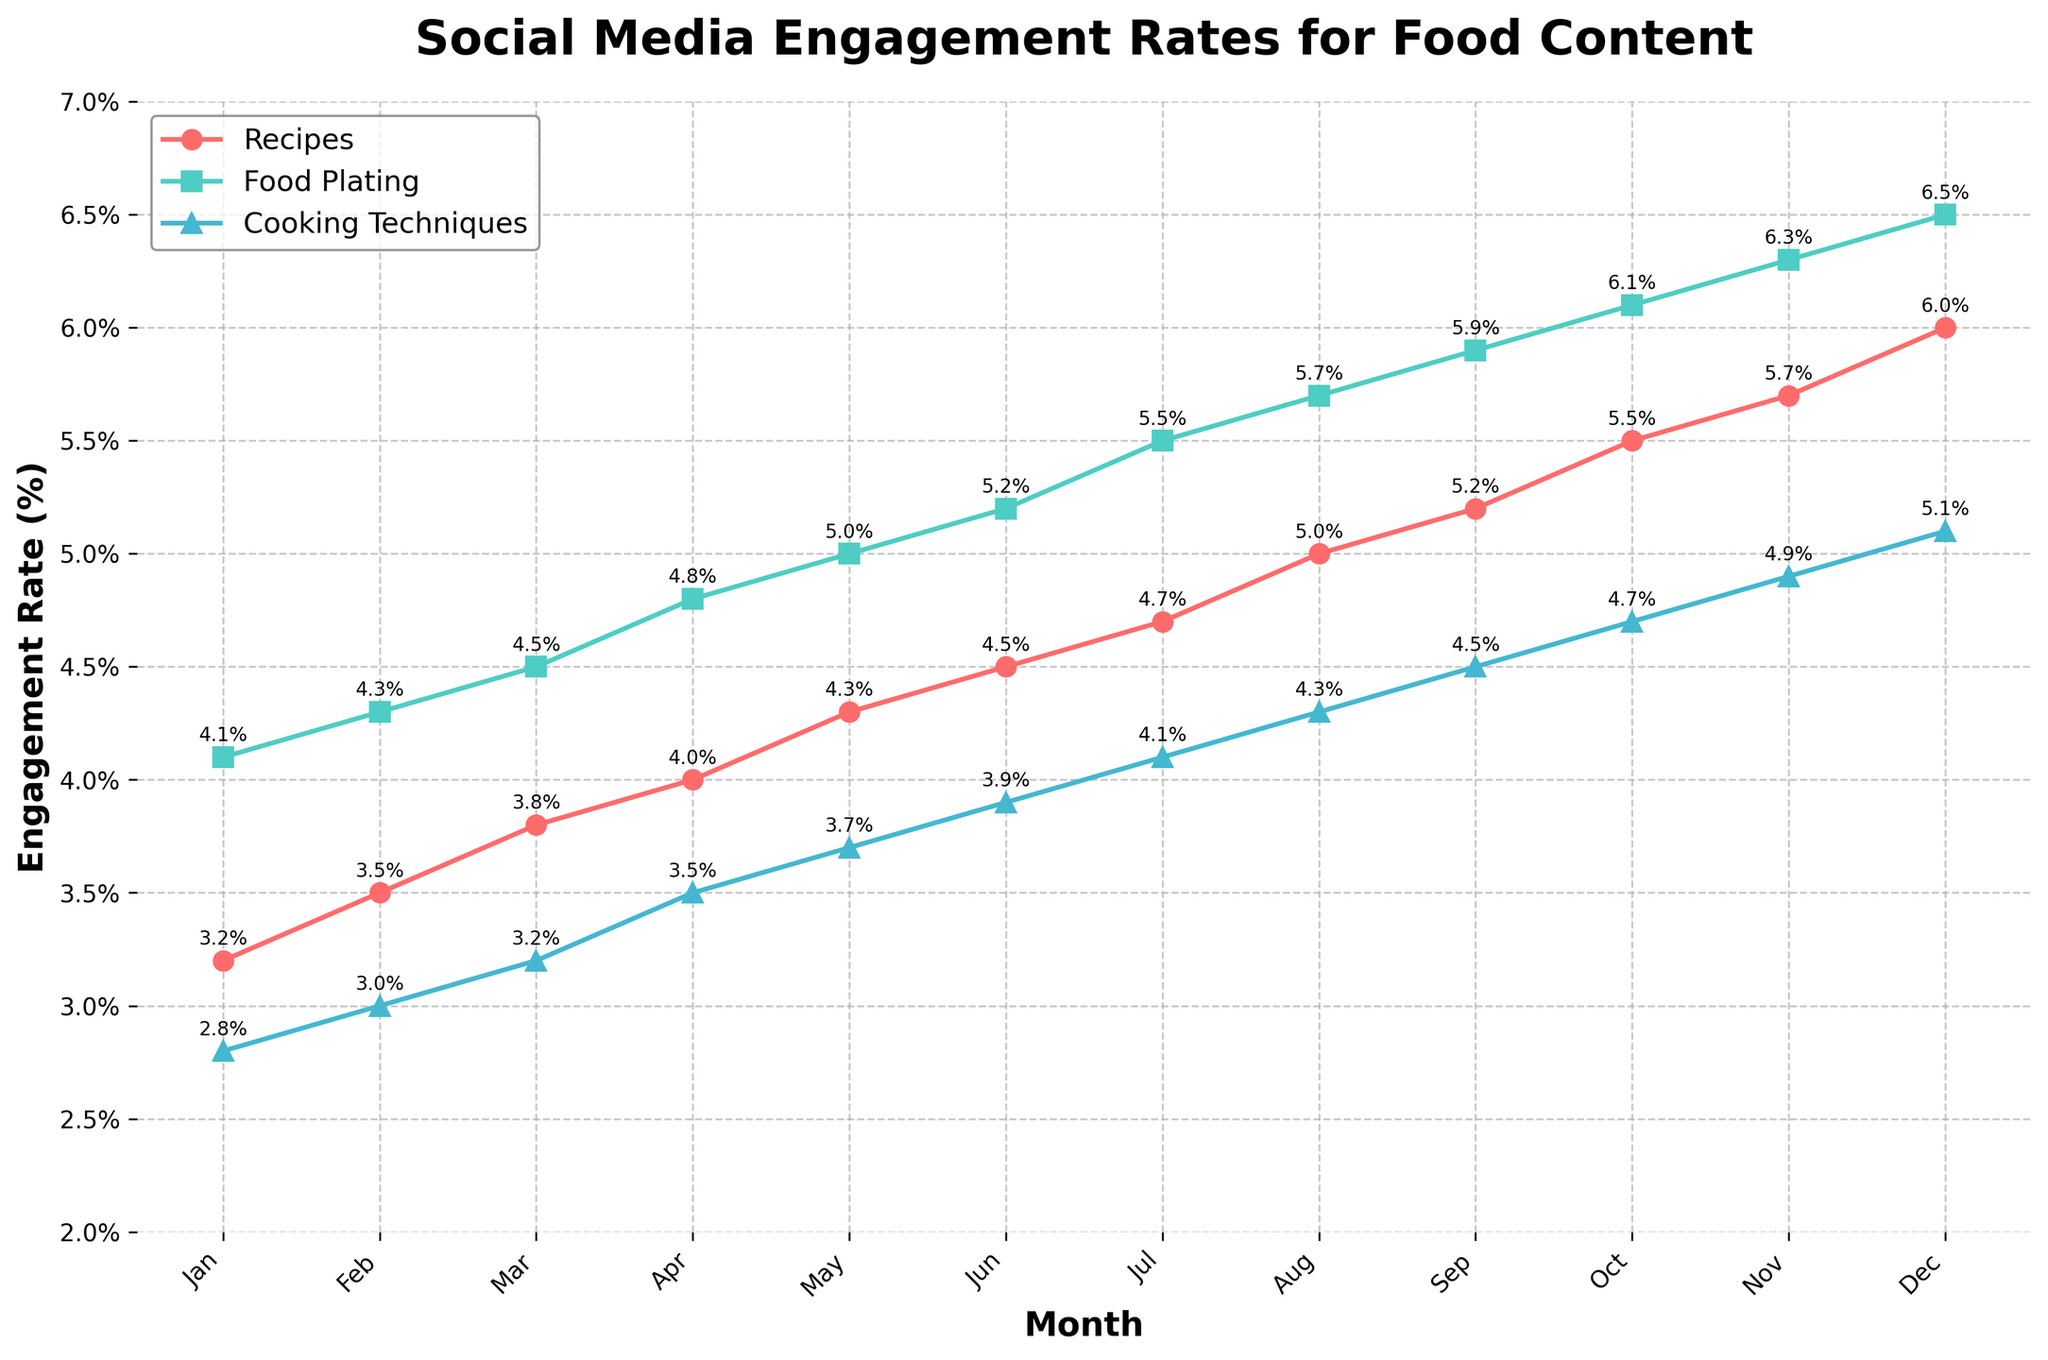How does the engagement rate for food plating compare to recipes in February? To compare, look at the February data for both food plating and recipes. Food plating has an engagement rate of 4.3% while recipes have 3.5%. Thus, food plating's engagement rate is higher than recipes in February.
Answer: Food plating is higher In which month do recipes hit the highest engagement rate, and what is it? Check the trend for the Recipes line. The highest engagement rate for recipes is in December at 6.0%.
Answer: December, 6.0% What is the average engagement rate for cooking techniques over the year? Sum the monthly engagement rates for cooking techniques and divide by 12: (2.8 + 3.0 + 3.2 + 3.5 + 3.7 + 3.9 + 4.1 + 4.3 + 4.5 + 4.7 + 4.9 + 5.1) / 12 = 3.95%.
Answer: 3.95% Which type of food content has the least engagement rate in January, and what is the rate? Compare the engagement rates for January. Cooking techniques have the lowest rate at 2.8%.
Answer: Cooking techniques, 2.8% Among the three types of content, which one shows the most steady month-to-month increase? Observe the general trends for each type of content. Recipes and food plating show similar steady increases, but plating has smaller incremental changes monthly compared to recipes.
Answer: Food plating 